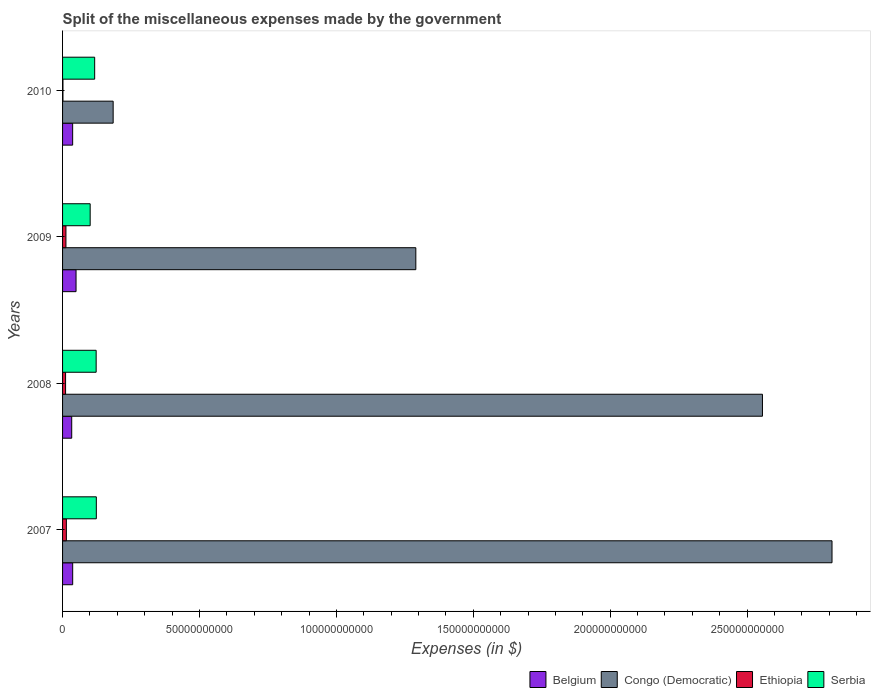How many different coloured bars are there?
Keep it short and to the point. 4. How many bars are there on the 3rd tick from the bottom?
Your response must be concise. 4. What is the label of the 3rd group of bars from the top?
Your answer should be very brief. 2008. In how many cases, is the number of bars for a given year not equal to the number of legend labels?
Offer a very short reply. 0. What is the miscellaneous expenses made by the government in Serbia in 2010?
Offer a very short reply. 1.17e+1. Across all years, what is the maximum miscellaneous expenses made by the government in Congo (Democratic)?
Ensure brevity in your answer.  2.81e+11. Across all years, what is the minimum miscellaneous expenses made by the government in Ethiopia?
Offer a terse response. 1.39e+08. In which year was the miscellaneous expenses made by the government in Congo (Democratic) maximum?
Keep it short and to the point. 2007. In which year was the miscellaneous expenses made by the government in Congo (Democratic) minimum?
Give a very brief answer. 2010. What is the total miscellaneous expenses made by the government in Congo (Democratic) in the graph?
Your answer should be very brief. 6.84e+11. What is the difference between the miscellaneous expenses made by the government in Congo (Democratic) in 2008 and that in 2009?
Offer a terse response. 1.27e+11. What is the difference between the miscellaneous expenses made by the government in Belgium in 2009 and the miscellaneous expenses made by the government in Congo (Democratic) in 2007?
Provide a short and direct response. -2.76e+11. What is the average miscellaneous expenses made by the government in Serbia per year?
Provide a short and direct response. 1.16e+1. In the year 2007, what is the difference between the miscellaneous expenses made by the government in Belgium and miscellaneous expenses made by the government in Congo (Democratic)?
Your response must be concise. -2.77e+11. What is the ratio of the miscellaneous expenses made by the government in Ethiopia in 2008 to that in 2010?
Your answer should be very brief. 7.94. Is the difference between the miscellaneous expenses made by the government in Belgium in 2007 and 2009 greater than the difference between the miscellaneous expenses made by the government in Congo (Democratic) in 2007 and 2009?
Your answer should be compact. No. What is the difference between the highest and the second highest miscellaneous expenses made by the government in Ethiopia?
Your answer should be very brief. 1.60e+08. What is the difference between the highest and the lowest miscellaneous expenses made by the government in Belgium?
Your answer should be compact. 1.58e+09. Is it the case that in every year, the sum of the miscellaneous expenses made by the government in Ethiopia and miscellaneous expenses made by the government in Belgium is greater than the sum of miscellaneous expenses made by the government in Congo (Democratic) and miscellaneous expenses made by the government in Serbia?
Provide a short and direct response. No. What does the 3rd bar from the top in 2010 represents?
Ensure brevity in your answer.  Congo (Democratic). What does the 3rd bar from the bottom in 2007 represents?
Provide a succinct answer. Ethiopia. Is it the case that in every year, the sum of the miscellaneous expenses made by the government in Congo (Democratic) and miscellaneous expenses made by the government in Ethiopia is greater than the miscellaneous expenses made by the government in Serbia?
Make the answer very short. Yes. How many years are there in the graph?
Provide a succinct answer. 4. Are the values on the major ticks of X-axis written in scientific E-notation?
Your response must be concise. No. Does the graph contain any zero values?
Your answer should be compact. No. How many legend labels are there?
Give a very brief answer. 4. What is the title of the graph?
Offer a very short reply. Split of the miscellaneous expenses made by the government. Does "Turks and Caicos Islands" appear as one of the legend labels in the graph?
Give a very brief answer. No. What is the label or title of the X-axis?
Provide a short and direct response. Expenses (in $). What is the Expenses (in $) in Belgium in 2007?
Your answer should be compact. 3.70e+09. What is the Expenses (in $) of Congo (Democratic) in 2007?
Make the answer very short. 2.81e+11. What is the Expenses (in $) in Ethiopia in 2007?
Provide a succinct answer. 1.39e+09. What is the Expenses (in $) in Serbia in 2007?
Provide a short and direct response. 1.23e+1. What is the Expenses (in $) in Belgium in 2008?
Ensure brevity in your answer.  3.34e+09. What is the Expenses (in $) in Congo (Democratic) in 2008?
Make the answer very short. 2.56e+11. What is the Expenses (in $) in Ethiopia in 2008?
Offer a very short reply. 1.10e+09. What is the Expenses (in $) of Serbia in 2008?
Make the answer very short. 1.23e+1. What is the Expenses (in $) of Belgium in 2009?
Keep it short and to the point. 4.92e+09. What is the Expenses (in $) of Congo (Democratic) in 2009?
Your answer should be compact. 1.29e+11. What is the Expenses (in $) in Ethiopia in 2009?
Your answer should be very brief. 1.23e+09. What is the Expenses (in $) in Serbia in 2009?
Give a very brief answer. 1.01e+1. What is the Expenses (in $) of Belgium in 2010?
Give a very brief answer. 3.68e+09. What is the Expenses (in $) of Congo (Democratic) in 2010?
Provide a succinct answer. 1.85e+1. What is the Expenses (in $) in Ethiopia in 2010?
Provide a short and direct response. 1.39e+08. What is the Expenses (in $) in Serbia in 2010?
Offer a terse response. 1.17e+1. Across all years, what is the maximum Expenses (in $) of Belgium?
Your answer should be compact. 4.92e+09. Across all years, what is the maximum Expenses (in $) in Congo (Democratic)?
Your answer should be very brief. 2.81e+11. Across all years, what is the maximum Expenses (in $) of Ethiopia?
Your answer should be compact. 1.39e+09. Across all years, what is the maximum Expenses (in $) in Serbia?
Offer a terse response. 1.23e+1. Across all years, what is the minimum Expenses (in $) in Belgium?
Your answer should be very brief. 3.34e+09. Across all years, what is the minimum Expenses (in $) in Congo (Democratic)?
Offer a very short reply. 1.85e+1. Across all years, what is the minimum Expenses (in $) of Ethiopia?
Make the answer very short. 1.39e+08. Across all years, what is the minimum Expenses (in $) of Serbia?
Ensure brevity in your answer.  1.01e+1. What is the total Expenses (in $) in Belgium in the graph?
Provide a short and direct response. 1.56e+1. What is the total Expenses (in $) of Congo (Democratic) in the graph?
Provide a short and direct response. 6.84e+11. What is the total Expenses (in $) of Ethiopia in the graph?
Make the answer very short. 3.86e+09. What is the total Expenses (in $) in Serbia in the graph?
Ensure brevity in your answer.  4.64e+1. What is the difference between the Expenses (in $) of Belgium in 2007 and that in 2008?
Provide a short and direct response. 3.53e+08. What is the difference between the Expenses (in $) in Congo (Democratic) in 2007 and that in 2008?
Offer a very short reply. 2.54e+1. What is the difference between the Expenses (in $) in Ethiopia in 2007 and that in 2008?
Offer a terse response. 2.89e+08. What is the difference between the Expenses (in $) in Serbia in 2007 and that in 2008?
Provide a succinct answer. 6.43e+07. What is the difference between the Expenses (in $) in Belgium in 2007 and that in 2009?
Your answer should be compact. -1.23e+09. What is the difference between the Expenses (in $) of Congo (Democratic) in 2007 and that in 2009?
Your answer should be very brief. 1.52e+11. What is the difference between the Expenses (in $) in Ethiopia in 2007 and that in 2009?
Offer a very short reply. 1.60e+08. What is the difference between the Expenses (in $) of Serbia in 2007 and that in 2009?
Provide a short and direct response. 2.25e+09. What is the difference between the Expenses (in $) of Belgium in 2007 and that in 2010?
Your answer should be very brief. 1.34e+07. What is the difference between the Expenses (in $) in Congo (Democratic) in 2007 and that in 2010?
Your response must be concise. 2.63e+11. What is the difference between the Expenses (in $) in Ethiopia in 2007 and that in 2010?
Your answer should be very brief. 1.25e+09. What is the difference between the Expenses (in $) of Serbia in 2007 and that in 2010?
Ensure brevity in your answer.  6.10e+08. What is the difference between the Expenses (in $) in Belgium in 2008 and that in 2009?
Your response must be concise. -1.58e+09. What is the difference between the Expenses (in $) of Congo (Democratic) in 2008 and that in 2009?
Make the answer very short. 1.27e+11. What is the difference between the Expenses (in $) in Ethiopia in 2008 and that in 2009?
Offer a terse response. -1.29e+08. What is the difference between the Expenses (in $) in Serbia in 2008 and that in 2009?
Make the answer very short. 2.19e+09. What is the difference between the Expenses (in $) of Belgium in 2008 and that in 2010?
Keep it short and to the point. -3.39e+08. What is the difference between the Expenses (in $) in Congo (Democratic) in 2008 and that in 2010?
Your answer should be very brief. 2.37e+11. What is the difference between the Expenses (in $) of Ethiopia in 2008 and that in 2010?
Offer a very short reply. 9.62e+08. What is the difference between the Expenses (in $) in Serbia in 2008 and that in 2010?
Provide a succinct answer. 5.46e+08. What is the difference between the Expenses (in $) of Belgium in 2009 and that in 2010?
Make the answer very short. 1.24e+09. What is the difference between the Expenses (in $) of Congo (Democratic) in 2009 and that in 2010?
Provide a short and direct response. 1.11e+11. What is the difference between the Expenses (in $) in Ethiopia in 2009 and that in 2010?
Give a very brief answer. 1.09e+09. What is the difference between the Expenses (in $) of Serbia in 2009 and that in 2010?
Ensure brevity in your answer.  -1.64e+09. What is the difference between the Expenses (in $) in Belgium in 2007 and the Expenses (in $) in Congo (Democratic) in 2008?
Offer a very short reply. -2.52e+11. What is the difference between the Expenses (in $) of Belgium in 2007 and the Expenses (in $) of Ethiopia in 2008?
Keep it short and to the point. 2.60e+09. What is the difference between the Expenses (in $) in Belgium in 2007 and the Expenses (in $) in Serbia in 2008?
Your response must be concise. -8.57e+09. What is the difference between the Expenses (in $) of Congo (Democratic) in 2007 and the Expenses (in $) of Ethiopia in 2008?
Ensure brevity in your answer.  2.80e+11. What is the difference between the Expenses (in $) of Congo (Democratic) in 2007 and the Expenses (in $) of Serbia in 2008?
Provide a succinct answer. 2.69e+11. What is the difference between the Expenses (in $) of Ethiopia in 2007 and the Expenses (in $) of Serbia in 2008?
Ensure brevity in your answer.  -1.09e+1. What is the difference between the Expenses (in $) in Belgium in 2007 and the Expenses (in $) in Congo (Democratic) in 2009?
Give a very brief answer. -1.25e+11. What is the difference between the Expenses (in $) in Belgium in 2007 and the Expenses (in $) in Ethiopia in 2009?
Provide a short and direct response. 2.47e+09. What is the difference between the Expenses (in $) in Belgium in 2007 and the Expenses (in $) in Serbia in 2009?
Keep it short and to the point. -6.39e+09. What is the difference between the Expenses (in $) of Congo (Democratic) in 2007 and the Expenses (in $) of Ethiopia in 2009?
Offer a very short reply. 2.80e+11. What is the difference between the Expenses (in $) in Congo (Democratic) in 2007 and the Expenses (in $) in Serbia in 2009?
Offer a very short reply. 2.71e+11. What is the difference between the Expenses (in $) of Ethiopia in 2007 and the Expenses (in $) of Serbia in 2009?
Offer a very short reply. -8.69e+09. What is the difference between the Expenses (in $) of Belgium in 2007 and the Expenses (in $) of Congo (Democratic) in 2010?
Offer a terse response. -1.48e+1. What is the difference between the Expenses (in $) in Belgium in 2007 and the Expenses (in $) in Ethiopia in 2010?
Your response must be concise. 3.56e+09. What is the difference between the Expenses (in $) in Belgium in 2007 and the Expenses (in $) in Serbia in 2010?
Make the answer very short. -8.03e+09. What is the difference between the Expenses (in $) of Congo (Democratic) in 2007 and the Expenses (in $) of Ethiopia in 2010?
Your answer should be very brief. 2.81e+11. What is the difference between the Expenses (in $) of Congo (Democratic) in 2007 and the Expenses (in $) of Serbia in 2010?
Offer a very short reply. 2.69e+11. What is the difference between the Expenses (in $) of Ethiopia in 2007 and the Expenses (in $) of Serbia in 2010?
Your answer should be compact. -1.03e+1. What is the difference between the Expenses (in $) of Belgium in 2008 and the Expenses (in $) of Congo (Democratic) in 2009?
Keep it short and to the point. -1.26e+11. What is the difference between the Expenses (in $) in Belgium in 2008 and the Expenses (in $) in Ethiopia in 2009?
Give a very brief answer. 2.11e+09. What is the difference between the Expenses (in $) of Belgium in 2008 and the Expenses (in $) of Serbia in 2009?
Offer a terse response. -6.74e+09. What is the difference between the Expenses (in $) of Congo (Democratic) in 2008 and the Expenses (in $) of Ethiopia in 2009?
Provide a succinct answer. 2.54e+11. What is the difference between the Expenses (in $) of Congo (Democratic) in 2008 and the Expenses (in $) of Serbia in 2009?
Your answer should be compact. 2.46e+11. What is the difference between the Expenses (in $) in Ethiopia in 2008 and the Expenses (in $) in Serbia in 2009?
Provide a short and direct response. -8.98e+09. What is the difference between the Expenses (in $) in Belgium in 2008 and the Expenses (in $) in Congo (Democratic) in 2010?
Offer a terse response. -1.51e+1. What is the difference between the Expenses (in $) of Belgium in 2008 and the Expenses (in $) of Ethiopia in 2010?
Your response must be concise. 3.20e+09. What is the difference between the Expenses (in $) in Belgium in 2008 and the Expenses (in $) in Serbia in 2010?
Keep it short and to the point. -8.38e+09. What is the difference between the Expenses (in $) of Congo (Democratic) in 2008 and the Expenses (in $) of Ethiopia in 2010?
Your response must be concise. 2.55e+11. What is the difference between the Expenses (in $) of Congo (Democratic) in 2008 and the Expenses (in $) of Serbia in 2010?
Provide a short and direct response. 2.44e+11. What is the difference between the Expenses (in $) of Ethiopia in 2008 and the Expenses (in $) of Serbia in 2010?
Keep it short and to the point. -1.06e+1. What is the difference between the Expenses (in $) in Belgium in 2009 and the Expenses (in $) in Congo (Democratic) in 2010?
Make the answer very short. -1.35e+1. What is the difference between the Expenses (in $) of Belgium in 2009 and the Expenses (in $) of Ethiopia in 2010?
Your answer should be very brief. 4.78e+09. What is the difference between the Expenses (in $) in Belgium in 2009 and the Expenses (in $) in Serbia in 2010?
Offer a terse response. -6.80e+09. What is the difference between the Expenses (in $) of Congo (Democratic) in 2009 and the Expenses (in $) of Ethiopia in 2010?
Make the answer very short. 1.29e+11. What is the difference between the Expenses (in $) of Congo (Democratic) in 2009 and the Expenses (in $) of Serbia in 2010?
Keep it short and to the point. 1.17e+11. What is the difference between the Expenses (in $) of Ethiopia in 2009 and the Expenses (in $) of Serbia in 2010?
Make the answer very short. -1.05e+1. What is the average Expenses (in $) in Belgium per year?
Offer a terse response. 3.91e+09. What is the average Expenses (in $) in Congo (Democratic) per year?
Make the answer very short. 1.71e+11. What is the average Expenses (in $) of Ethiopia per year?
Keep it short and to the point. 9.65e+08. What is the average Expenses (in $) in Serbia per year?
Your response must be concise. 1.16e+1. In the year 2007, what is the difference between the Expenses (in $) in Belgium and Expenses (in $) in Congo (Democratic)?
Make the answer very short. -2.77e+11. In the year 2007, what is the difference between the Expenses (in $) in Belgium and Expenses (in $) in Ethiopia?
Offer a terse response. 2.31e+09. In the year 2007, what is the difference between the Expenses (in $) in Belgium and Expenses (in $) in Serbia?
Your answer should be compact. -8.64e+09. In the year 2007, what is the difference between the Expenses (in $) of Congo (Democratic) and Expenses (in $) of Ethiopia?
Give a very brief answer. 2.80e+11. In the year 2007, what is the difference between the Expenses (in $) in Congo (Democratic) and Expenses (in $) in Serbia?
Offer a terse response. 2.69e+11. In the year 2007, what is the difference between the Expenses (in $) in Ethiopia and Expenses (in $) in Serbia?
Offer a very short reply. -1.09e+1. In the year 2008, what is the difference between the Expenses (in $) in Belgium and Expenses (in $) in Congo (Democratic)?
Offer a very short reply. -2.52e+11. In the year 2008, what is the difference between the Expenses (in $) of Belgium and Expenses (in $) of Ethiopia?
Offer a very short reply. 2.24e+09. In the year 2008, what is the difference between the Expenses (in $) in Belgium and Expenses (in $) in Serbia?
Give a very brief answer. -8.92e+09. In the year 2008, what is the difference between the Expenses (in $) of Congo (Democratic) and Expenses (in $) of Ethiopia?
Provide a short and direct response. 2.54e+11. In the year 2008, what is the difference between the Expenses (in $) in Congo (Democratic) and Expenses (in $) in Serbia?
Provide a short and direct response. 2.43e+11. In the year 2008, what is the difference between the Expenses (in $) of Ethiopia and Expenses (in $) of Serbia?
Your answer should be very brief. -1.12e+1. In the year 2009, what is the difference between the Expenses (in $) in Belgium and Expenses (in $) in Congo (Democratic)?
Give a very brief answer. -1.24e+11. In the year 2009, what is the difference between the Expenses (in $) in Belgium and Expenses (in $) in Ethiopia?
Offer a very short reply. 3.69e+09. In the year 2009, what is the difference between the Expenses (in $) of Belgium and Expenses (in $) of Serbia?
Keep it short and to the point. -5.16e+09. In the year 2009, what is the difference between the Expenses (in $) of Congo (Democratic) and Expenses (in $) of Ethiopia?
Ensure brevity in your answer.  1.28e+11. In the year 2009, what is the difference between the Expenses (in $) in Congo (Democratic) and Expenses (in $) in Serbia?
Give a very brief answer. 1.19e+11. In the year 2009, what is the difference between the Expenses (in $) in Ethiopia and Expenses (in $) in Serbia?
Make the answer very short. -8.85e+09. In the year 2010, what is the difference between the Expenses (in $) in Belgium and Expenses (in $) in Congo (Democratic)?
Give a very brief answer. -1.48e+1. In the year 2010, what is the difference between the Expenses (in $) in Belgium and Expenses (in $) in Ethiopia?
Provide a succinct answer. 3.54e+09. In the year 2010, what is the difference between the Expenses (in $) of Belgium and Expenses (in $) of Serbia?
Your answer should be compact. -8.04e+09. In the year 2010, what is the difference between the Expenses (in $) in Congo (Democratic) and Expenses (in $) in Ethiopia?
Offer a terse response. 1.83e+1. In the year 2010, what is the difference between the Expenses (in $) of Congo (Democratic) and Expenses (in $) of Serbia?
Ensure brevity in your answer.  6.75e+09. In the year 2010, what is the difference between the Expenses (in $) in Ethiopia and Expenses (in $) in Serbia?
Ensure brevity in your answer.  -1.16e+1. What is the ratio of the Expenses (in $) of Belgium in 2007 to that in 2008?
Give a very brief answer. 1.11. What is the ratio of the Expenses (in $) of Congo (Democratic) in 2007 to that in 2008?
Keep it short and to the point. 1.1. What is the ratio of the Expenses (in $) of Ethiopia in 2007 to that in 2008?
Offer a very short reply. 1.26. What is the ratio of the Expenses (in $) of Belgium in 2007 to that in 2009?
Your response must be concise. 0.75. What is the ratio of the Expenses (in $) of Congo (Democratic) in 2007 to that in 2009?
Give a very brief answer. 2.18. What is the ratio of the Expenses (in $) in Ethiopia in 2007 to that in 2009?
Provide a short and direct response. 1.13. What is the ratio of the Expenses (in $) in Serbia in 2007 to that in 2009?
Your response must be concise. 1.22. What is the ratio of the Expenses (in $) of Congo (Democratic) in 2007 to that in 2010?
Your answer should be very brief. 15.21. What is the ratio of the Expenses (in $) in Ethiopia in 2007 to that in 2010?
Provide a short and direct response. 10.02. What is the ratio of the Expenses (in $) of Serbia in 2007 to that in 2010?
Your response must be concise. 1.05. What is the ratio of the Expenses (in $) in Belgium in 2008 to that in 2009?
Offer a terse response. 0.68. What is the ratio of the Expenses (in $) of Congo (Democratic) in 2008 to that in 2009?
Your answer should be compact. 1.98. What is the ratio of the Expenses (in $) in Ethiopia in 2008 to that in 2009?
Provide a succinct answer. 0.9. What is the ratio of the Expenses (in $) in Serbia in 2008 to that in 2009?
Ensure brevity in your answer.  1.22. What is the ratio of the Expenses (in $) of Belgium in 2008 to that in 2010?
Make the answer very short. 0.91. What is the ratio of the Expenses (in $) of Congo (Democratic) in 2008 to that in 2010?
Provide a succinct answer. 13.84. What is the ratio of the Expenses (in $) in Ethiopia in 2008 to that in 2010?
Give a very brief answer. 7.94. What is the ratio of the Expenses (in $) of Serbia in 2008 to that in 2010?
Provide a short and direct response. 1.05. What is the ratio of the Expenses (in $) in Belgium in 2009 to that in 2010?
Offer a very short reply. 1.34. What is the ratio of the Expenses (in $) in Congo (Democratic) in 2009 to that in 2010?
Offer a very short reply. 6.98. What is the ratio of the Expenses (in $) in Ethiopia in 2009 to that in 2010?
Provide a succinct answer. 8.86. What is the ratio of the Expenses (in $) in Serbia in 2009 to that in 2010?
Give a very brief answer. 0.86. What is the difference between the highest and the second highest Expenses (in $) in Belgium?
Offer a terse response. 1.23e+09. What is the difference between the highest and the second highest Expenses (in $) of Congo (Democratic)?
Provide a succinct answer. 2.54e+1. What is the difference between the highest and the second highest Expenses (in $) in Ethiopia?
Keep it short and to the point. 1.60e+08. What is the difference between the highest and the second highest Expenses (in $) in Serbia?
Offer a very short reply. 6.43e+07. What is the difference between the highest and the lowest Expenses (in $) in Belgium?
Your answer should be compact. 1.58e+09. What is the difference between the highest and the lowest Expenses (in $) in Congo (Democratic)?
Offer a very short reply. 2.63e+11. What is the difference between the highest and the lowest Expenses (in $) in Ethiopia?
Offer a terse response. 1.25e+09. What is the difference between the highest and the lowest Expenses (in $) in Serbia?
Your answer should be very brief. 2.25e+09. 